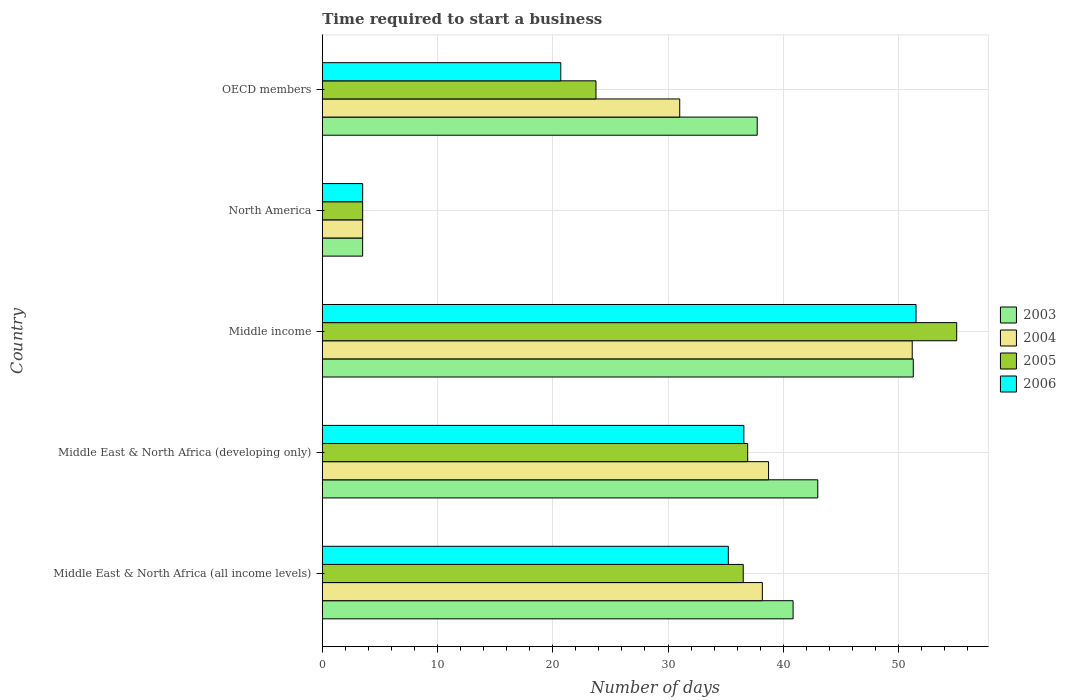How many different coloured bars are there?
Provide a succinct answer. 4. How many groups of bars are there?
Ensure brevity in your answer.  5. How many bars are there on the 5th tick from the bottom?
Ensure brevity in your answer.  4. What is the label of the 5th group of bars from the top?
Provide a succinct answer. Middle East & North Africa (all income levels). What is the number of days required to start a business in 2005 in North America?
Keep it short and to the point. 3.5. Across all countries, what is the maximum number of days required to start a business in 2003?
Offer a very short reply. 51.29. Across all countries, what is the minimum number of days required to start a business in 2006?
Offer a terse response. 3.5. In which country was the number of days required to start a business in 2005 minimum?
Your answer should be compact. North America. What is the total number of days required to start a business in 2004 in the graph?
Provide a succinct answer. 162.63. What is the difference between the number of days required to start a business in 2004 in Middle East & North Africa (all income levels) and that in Middle East & North Africa (developing only)?
Your answer should be compact. -0.54. What is the difference between the number of days required to start a business in 2004 in Middle East & North Africa (all income levels) and the number of days required to start a business in 2005 in North America?
Your answer should be very brief. 34.69. What is the average number of days required to start a business in 2003 per country?
Provide a short and direct response. 35.28. What is the difference between the number of days required to start a business in 2006 and number of days required to start a business in 2004 in OECD members?
Make the answer very short. -10.32. In how many countries, is the number of days required to start a business in 2004 greater than 38 days?
Ensure brevity in your answer.  3. What is the ratio of the number of days required to start a business in 2006 in Middle income to that in North America?
Give a very brief answer. 14.72. Is the number of days required to start a business in 2006 in Middle East & North Africa (all income levels) less than that in OECD members?
Keep it short and to the point. No. Is the difference between the number of days required to start a business in 2006 in Middle East & North Africa (all income levels) and Middle income greater than the difference between the number of days required to start a business in 2004 in Middle East & North Africa (all income levels) and Middle income?
Your answer should be very brief. No. What is the difference between the highest and the second highest number of days required to start a business in 2004?
Offer a very short reply. 12.47. What is the difference between the highest and the lowest number of days required to start a business in 2005?
Your answer should be very brief. 51.56. Is the sum of the number of days required to start a business in 2006 in Middle East & North Africa (all income levels) and North America greater than the maximum number of days required to start a business in 2004 across all countries?
Your answer should be very brief. No. Is it the case that in every country, the sum of the number of days required to start a business in 2006 and number of days required to start a business in 2003 is greater than the sum of number of days required to start a business in 2005 and number of days required to start a business in 2004?
Ensure brevity in your answer.  No. What does the 4th bar from the bottom in Middle East & North Africa (developing only) represents?
Ensure brevity in your answer.  2006. How many countries are there in the graph?
Offer a very short reply. 5. Does the graph contain any zero values?
Offer a very short reply. No. Where does the legend appear in the graph?
Keep it short and to the point. Center right. How many legend labels are there?
Your answer should be very brief. 4. What is the title of the graph?
Your response must be concise. Time required to start a business. Does "2009" appear as one of the legend labels in the graph?
Provide a succinct answer. No. What is the label or title of the X-axis?
Your response must be concise. Number of days. What is the label or title of the Y-axis?
Your response must be concise. Country. What is the Number of days of 2003 in Middle East & North Africa (all income levels)?
Provide a succinct answer. 40.86. What is the Number of days of 2004 in Middle East & North Africa (all income levels)?
Your answer should be compact. 38.19. What is the Number of days of 2005 in Middle East & North Africa (all income levels)?
Offer a terse response. 36.53. What is the Number of days in 2006 in Middle East & North Africa (all income levels)?
Offer a very short reply. 35.24. What is the Number of days in 2004 in Middle East & North Africa (developing only)?
Offer a very short reply. 38.73. What is the Number of days in 2005 in Middle East & North Africa (developing only)?
Your response must be concise. 36.92. What is the Number of days of 2006 in Middle East & North Africa (developing only)?
Ensure brevity in your answer.  36.58. What is the Number of days in 2003 in Middle income?
Offer a terse response. 51.29. What is the Number of days of 2004 in Middle income?
Provide a succinct answer. 51.19. What is the Number of days of 2005 in Middle income?
Your answer should be compact. 55.06. What is the Number of days in 2006 in Middle income?
Provide a short and direct response. 51.53. What is the Number of days in 2003 in North America?
Offer a terse response. 3.5. What is the Number of days in 2006 in North America?
Offer a very short reply. 3.5. What is the Number of days of 2003 in OECD members?
Keep it short and to the point. 37.74. What is the Number of days in 2004 in OECD members?
Your answer should be compact. 31.02. What is the Number of days of 2005 in OECD members?
Provide a short and direct response. 23.75. What is the Number of days in 2006 in OECD members?
Ensure brevity in your answer.  20.69. Across all countries, what is the maximum Number of days in 2003?
Provide a short and direct response. 51.29. Across all countries, what is the maximum Number of days of 2004?
Your response must be concise. 51.19. Across all countries, what is the maximum Number of days in 2005?
Ensure brevity in your answer.  55.06. Across all countries, what is the maximum Number of days in 2006?
Provide a short and direct response. 51.53. Across all countries, what is the minimum Number of days in 2005?
Offer a terse response. 3.5. Across all countries, what is the minimum Number of days of 2006?
Your answer should be very brief. 3.5. What is the total Number of days of 2003 in the graph?
Ensure brevity in your answer.  176.38. What is the total Number of days of 2004 in the graph?
Give a very brief answer. 162.63. What is the total Number of days of 2005 in the graph?
Provide a short and direct response. 155.75. What is the total Number of days of 2006 in the graph?
Offer a very short reply. 147.54. What is the difference between the Number of days of 2003 in Middle East & North Africa (all income levels) and that in Middle East & North Africa (developing only)?
Offer a terse response. -2.14. What is the difference between the Number of days in 2004 in Middle East & North Africa (all income levels) and that in Middle East & North Africa (developing only)?
Ensure brevity in your answer.  -0.54. What is the difference between the Number of days of 2005 in Middle East & North Africa (all income levels) and that in Middle East & North Africa (developing only)?
Offer a terse response. -0.39. What is the difference between the Number of days in 2006 in Middle East & North Africa (all income levels) and that in Middle East & North Africa (developing only)?
Give a very brief answer. -1.35. What is the difference between the Number of days in 2003 in Middle East & North Africa (all income levels) and that in Middle income?
Provide a succinct answer. -10.43. What is the difference between the Number of days of 2004 in Middle East & North Africa (all income levels) and that in Middle income?
Make the answer very short. -13.01. What is the difference between the Number of days of 2005 in Middle East & North Africa (all income levels) and that in Middle income?
Offer a terse response. -18.53. What is the difference between the Number of days of 2006 in Middle East & North Africa (all income levels) and that in Middle income?
Provide a short and direct response. -16.29. What is the difference between the Number of days of 2003 in Middle East & North Africa (all income levels) and that in North America?
Your answer should be compact. 37.36. What is the difference between the Number of days of 2004 in Middle East & North Africa (all income levels) and that in North America?
Offer a very short reply. 34.69. What is the difference between the Number of days in 2005 in Middle East & North Africa (all income levels) and that in North America?
Provide a short and direct response. 33.03. What is the difference between the Number of days in 2006 in Middle East & North Africa (all income levels) and that in North America?
Provide a short and direct response. 31.74. What is the difference between the Number of days of 2003 in Middle East & North Africa (all income levels) and that in OECD members?
Offer a very short reply. 3.12. What is the difference between the Number of days in 2004 in Middle East & North Africa (all income levels) and that in OECD members?
Give a very brief answer. 7.17. What is the difference between the Number of days of 2005 in Middle East & North Africa (all income levels) and that in OECD members?
Your answer should be compact. 12.78. What is the difference between the Number of days of 2006 in Middle East & North Africa (all income levels) and that in OECD members?
Provide a succinct answer. 14.54. What is the difference between the Number of days of 2003 in Middle East & North Africa (developing only) and that in Middle income?
Offer a very short reply. -8.29. What is the difference between the Number of days in 2004 in Middle East & North Africa (developing only) and that in Middle income?
Your answer should be compact. -12.47. What is the difference between the Number of days of 2005 in Middle East & North Africa (developing only) and that in Middle income?
Give a very brief answer. -18.14. What is the difference between the Number of days of 2006 in Middle East & North Africa (developing only) and that in Middle income?
Your response must be concise. -14.94. What is the difference between the Number of days of 2003 in Middle East & North Africa (developing only) and that in North America?
Give a very brief answer. 39.5. What is the difference between the Number of days in 2004 in Middle East & North Africa (developing only) and that in North America?
Offer a terse response. 35.23. What is the difference between the Number of days of 2005 in Middle East & North Africa (developing only) and that in North America?
Give a very brief answer. 33.42. What is the difference between the Number of days of 2006 in Middle East & North Africa (developing only) and that in North America?
Provide a short and direct response. 33.08. What is the difference between the Number of days of 2003 in Middle East & North Africa (developing only) and that in OECD members?
Offer a terse response. 5.26. What is the difference between the Number of days of 2004 in Middle East & North Africa (developing only) and that in OECD members?
Give a very brief answer. 7.71. What is the difference between the Number of days in 2005 in Middle East & North Africa (developing only) and that in OECD members?
Ensure brevity in your answer.  13.17. What is the difference between the Number of days in 2006 in Middle East & North Africa (developing only) and that in OECD members?
Your answer should be very brief. 15.89. What is the difference between the Number of days of 2003 in Middle income and that in North America?
Provide a short and direct response. 47.79. What is the difference between the Number of days of 2004 in Middle income and that in North America?
Offer a terse response. 47.69. What is the difference between the Number of days of 2005 in Middle income and that in North America?
Ensure brevity in your answer.  51.56. What is the difference between the Number of days of 2006 in Middle income and that in North America?
Keep it short and to the point. 48.03. What is the difference between the Number of days in 2003 in Middle income and that in OECD members?
Your answer should be very brief. 13.54. What is the difference between the Number of days of 2004 in Middle income and that in OECD members?
Your answer should be very brief. 20.18. What is the difference between the Number of days of 2005 in Middle income and that in OECD members?
Provide a succinct answer. 31.31. What is the difference between the Number of days in 2006 in Middle income and that in OECD members?
Make the answer very short. 30.83. What is the difference between the Number of days in 2003 in North America and that in OECD members?
Make the answer very short. -34.24. What is the difference between the Number of days in 2004 in North America and that in OECD members?
Keep it short and to the point. -27.52. What is the difference between the Number of days of 2005 in North America and that in OECD members?
Provide a short and direct response. -20.25. What is the difference between the Number of days of 2006 in North America and that in OECD members?
Offer a terse response. -17.19. What is the difference between the Number of days in 2003 in Middle East & North Africa (all income levels) and the Number of days in 2004 in Middle East & North Africa (developing only)?
Ensure brevity in your answer.  2.13. What is the difference between the Number of days in 2003 in Middle East & North Africa (all income levels) and the Number of days in 2005 in Middle East & North Africa (developing only)?
Your response must be concise. 3.94. What is the difference between the Number of days of 2003 in Middle East & North Africa (all income levels) and the Number of days of 2006 in Middle East & North Africa (developing only)?
Your response must be concise. 4.27. What is the difference between the Number of days in 2004 in Middle East & North Africa (all income levels) and the Number of days in 2005 in Middle East & North Africa (developing only)?
Offer a very short reply. 1.27. What is the difference between the Number of days of 2004 in Middle East & North Africa (all income levels) and the Number of days of 2006 in Middle East & North Africa (developing only)?
Ensure brevity in your answer.  1.6. What is the difference between the Number of days of 2005 in Middle East & North Africa (all income levels) and the Number of days of 2006 in Middle East & North Africa (developing only)?
Your response must be concise. -0.05. What is the difference between the Number of days in 2003 in Middle East & North Africa (all income levels) and the Number of days in 2004 in Middle income?
Give a very brief answer. -10.34. What is the difference between the Number of days in 2003 in Middle East & North Africa (all income levels) and the Number of days in 2005 in Middle income?
Your answer should be very brief. -14.2. What is the difference between the Number of days of 2003 in Middle East & North Africa (all income levels) and the Number of days of 2006 in Middle income?
Keep it short and to the point. -10.67. What is the difference between the Number of days in 2004 in Middle East & North Africa (all income levels) and the Number of days in 2005 in Middle income?
Your response must be concise. -16.87. What is the difference between the Number of days of 2004 in Middle East & North Africa (all income levels) and the Number of days of 2006 in Middle income?
Give a very brief answer. -13.34. What is the difference between the Number of days of 2005 in Middle East & North Africa (all income levels) and the Number of days of 2006 in Middle income?
Offer a very short reply. -15. What is the difference between the Number of days of 2003 in Middle East & North Africa (all income levels) and the Number of days of 2004 in North America?
Offer a terse response. 37.36. What is the difference between the Number of days of 2003 in Middle East & North Africa (all income levels) and the Number of days of 2005 in North America?
Your response must be concise. 37.36. What is the difference between the Number of days of 2003 in Middle East & North Africa (all income levels) and the Number of days of 2006 in North America?
Provide a succinct answer. 37.36. What is the difference between the Number of days in 2004 in Middle East & North Africa (all income levels) and the Number of days in 2005 in North America?
Your response must be concise. 34.69. What is the difference between the Number of days of 2004 in Middle East & North Africa (all income levels) and the Number of days of 2006 in North America?
Keep it short and to the point. 34.69. What is the difference between the Number of days in 2005 in Middle East & North Africa (all income levels) and the Number of days in 2006 in North America?
Keep it short and to the point. 33.03. What is the difference between the Number of days in 2003 in Middle East & North Africa (all income levels) and the Number of days in 2004 in OECD members?
Provide a succinct answer. 9.84. What is the difference between the Number of days of 2003 in Middle East & North Africa (all income levels) and the Number of days of 2005 in OECD members?
Make the answer very short. 17.11. What is the difference between the Number of days of 2003 in Middle East & North Africa (all income levels) and the Number of days of 2006 in OECD members?
Provide a short and direct response. 20.16. What is the difference between the Number of days in 2004 in Middle East & North Africa (all income levels) and the Number of days in 2005 in OECD members?
Make the answer very short. 14.44. What is the difference between the Number of days in 2004 in Middle East & North Africa (all income levels) and the Number of days in 2006 in OECD members?
Offer a very short reply. 17.49. What is the difference between the Number of days in 2005 in Middle East & North Africa (all income levels) and the Number of days in 2006 in OECD members?
Offer a terse response. 15.84. What is the difference between the Number of days of 2003 in Middle East & North Africa (developing only) and the Number of days of 2004 in Middle income?
Your answer should be very brief. -8.19. What is the difference between the Number of days of 2003 in Middle East & North Africa (developing only) and the Number of days of 2005 in Middle income?
Offer a very short reply. -12.06. What is the difference between the Number of days of 2003 in Middle East & North Africa (developing only) and the Number of days of 2006 in Middle income?
Your answer should be compact. -8.53. What is the difference between the Number of days in 2004 in Middle East & North Africa (developing only) and the Number of days in 2005 in Middle income?
Provide a succinct answer. -16.33. What is the difference between the Number of days of 2004 in Middle East & North Africa (developing only) and the Number of days of 2006 in Middle income?
Provide a succinct answer. -12.8. What is the difference between the Number of days of 2005 in Middle East & North Africa (developing only) and the Number of days of 2006 in Middle income?
Your answer should be very brief. -14.61. What is the difference between the Number of days in 2003 in Middle East & North Africa (developing only) and the Number of days in 2004 in North America?
Ensure brevity in your answer.  39.5. What is the difference between the Number of days in 2003 in Middle East & North Africa (developing only) and the Number of days in 2005 in North America?
Offer a very short reply. 39.5. What is the difference between the Number of days in 2003 in Middle East & North Africa (developing only) and the Number of days in 2006 in North America?
Your answer should be very brief. 39.5. What is the difference between the Number of days in 2004 in Middle East & North Africa (developing only) and the Number of days in 2005 in North America?
Your response must be concise. 35.23. What is the difference between the Number of days of 2004 in Middle East & North Africa (developing only) and the Number of days of 2006 in North America?
Your answer should be compact. 35.23. What is the difference between the Number of days in 2005 in Middle East & North Africa (developing only) and the Number of days in 2006 in North America?
Offer a terse response. 33.42. What is the difference between the Number of days in 2003 in Middle East & North Africa (developing only) and the Number of days in 2004 in OECD members?
Provide a succinct answer. 11.98. What is the difference between the Number of days of 2003 in Middle East & North Africa (developing only) and the Number of days of 2005 in OECD members?
Ensure brevity in your answer.  19.25. What is the difference between the Number of days in 2003 in Middle East & North Africa (developing only) and the Number of days in 2006 in OECD members?
Your answer should be very brief. 22.31. What is the difference between the Number of days of 2004 in Middle East & North Africa (developing only) and the Number of days of 2005 in OECD members?
Your response must be concise. 14.98. What is the difference between the Number of days of 2004 in Middle East & North Africa (developing only) and the Number of days of 2006 in OECD members?
Make the answer very short. 18.03. What is the difference between the Number of days in 2005 in Middle East & North Africa (developing only) and the Number of days in 2006 in OECD members?
Keep it short and to the point. 16.22. What is the difference between the Number of days of 2003 in Middle income and the Number of days of 2004 in North America?
Your response must be concise. 47.79. What is the difference between the Number of days of 2003 in Middle income and the Number of days of 2005 in North America?
Ensure brevity in your answer.  47.79. What is the difference between the Number of days in 2003 in Middle income and the Number of days in 2006 in North America?
Give a very brief answer. 47.79. What is the difference between the Number of days of 2004 in Middle income and the Number of days of 2005 in North America?
Offer a terse response. 47.69. What is the difference between the Number of days in 2004 in Middle income and the Number of days in 2006 in North America?
Your answer should be very brief. 47.69. What is the difference between the Number of days of 2005 in Middle income and the Number of days of 2006 in North America?
Keep it short and to the point. 51.56. What is the difference between the Number of days of 2003 in Middle income and the Number of days of 2004 in OECD members?
Offer a very short reply. 20.27. What is the difference between the Number of days in 2003 in Middle income and the Number of days in 2005 in OECD members?
Provide a short and direct response. 27.54. What is the difference between the Number of days in 2003 in Middle income and the Number of days in 2006 in OECD members?
Provide a succinct answer. 30.59. What is the difference between the Number of days of 2004 in Middle income and the Number of days of 2005 in OECD members?
Make the answer very short. 27.44. What is the difference between the Number of days of 2004 in Middle income and the Number of days of 2006 in OECD members?
Keep it short and to the point. 30.5. What is the difference between the Number of days in 2005 in Middle income and the Number of days in 2006 in OECD members?
Give a very brief answer. 34.36. What is the difference between the Number of days of 2003 in North America and the Number of days of 2004 in OECD members?
Make the answer very short. -27.52. What is the difference between the Number of days of 2003 in North America and the Number of days of 2005 in OECD members?
Give a very brief answer. -20.25. What is the difference between the Number of days of 2003 in North America and the Number of days of 2006 in OECD members?
Provide a succinct answer. -17.19. What is the difference between the Number of days of 2004 in North America and the Number of days of 2005 in OECD members?
Offer a terse response. -20.25. What is the difference between the Number of days in 2004 in North America and the Number of days in 2006 in OECD members?
Keep it short and to the point. -17.19. What is the difference between the Number of days of 2005 in North America and the Number of days of 2006 in OECD members?
Your answer should be very brief. -17.19. What is the average Number of days of 2003 per country?
Provide a succinct answer. 35.28. What is the average Number of days of 2004 per country?
Offer a terse response. 32.53. What is the average Number of days in 2005 per country?
Your answer should be very brief. 31.15. What is the average Number of days of 2006 per country?
Your answer should be compact. 29.51. What is the difference between the Number of days of 2003 and Number of days of 2004 in Middle East & North Africa (all income levels)?
Your response must be concise. 2.67. What is the difference between the Number of days in 2003 and Number of days in 2005 in Middle East & North Africa (all income levels)?
Offer a terse response. 4.33. What is the difference between the Number of days of 2003 and Number of days of 2006 in Middle East & North Africa (all income levels)?
Your response must be concise. 5.62. What is the difference between the Number of days in 2004 and Number of days in 2005 in Middle East & North Africa (all income levels)?
Your answer should be very brief. 1.66. What is the difference between the Number of days in 2004 and Number of days in 2006 in Middle East & North Africa (all income levels)?
Your response must be concise. 2.95. What is the difference between the Number of days in 2005 and Number of days in 2006 in Middle East & North Africa (all income levels)?
Provide a succinct answer. 1.29. What is the difference between the Number of days in 2003 and Number of days in 2004 in Middle East & North Africa (developing only)?
Make the answer very short. 4.27. What is the difference between the Number of days in 2003 and Number of days in 2005 in Middle East & North Africa (developing only)?
Ensure brevity in your answer.  6.08. What is the difference between the Number of days of 2003 and Number of days of 2006 in Middle East & North Africa (developing only)?
Keep it short and to the point. 6.42. What is the difference between the Number of days of 2004 and Number of days of 2005 in Middle East & North Africa (developing only)?
Ensure brevity in your answer.  1.81. What is the difference between the Number of days of 2004 and Number of days of 2006 in Middle East & North Africa (developing only)?
Your response must be concise. 2.14. What is the difference between the Number of days in 2003 and Number of days in 2004 in Middle income?
Make the answer very short. 0.09. What is the difference between the Number of days of 2003 and Number of days of 2005 in Middle income?
Your answer should be compact. -3.77. What is the difference between the Number of days of 2003 and Number of days of 2006 in Middle income?
Keep it short and to the point. -0.24. What is the difference between the Number of days of 2004 and Number of days of 2005 in Middle income?
Provide a short and direct response. -3.86. What is the difference between the Number of days of 2004 and Number of days of 2006 in Middle income?
Give a very brief answer. -0.33. What is the difference between the Number of days in 2005 and Number of days in 2006 in Middle income?
Your response must be concise. 3.53. What is the difference between the Number of days of 2003 and Number of days of 2005 in North America?
Provide a succinct answer. 0. What is the difference between the Number of days in 2004 and Number of days in 2006 in North America?
Give a very brief answer. 0. What is the difference between the Number of days in 2005 and Number of days in 2006 in North America?
Give a very brief answer. 0. What is the difference between the Number of days of 2003 and Number of days of 2004 in OECD members?
Offer a very short reply. 6.72. What is the difference between the Number of days of 2003 and Number of days of 2005 in OECD members?
Offer a terse response. 13.99. What is the difference between the Number of days in 2003 and Number of days in 2006 in OECD members?
Offer a very short reply. 17.05. What is the difference between the Number of days in 2004 and Number of days in 2005 in OECD members?
Ensure brevity in your answer.  7.27. What is the difference between the Number of days of 2004 and Number of days of 2006 in OECD members?
Make the answer very short. 10.32. What is the difference between the Number of days in 2005 and Number of days in 2006 in OECD members?
Offer a terse response. 3.06. What is the ratio of the Number of days of 2003 in Middle East & North Africa (all income levels) to that in Middle East & North Africa (developing only)?
Your response must be concise. 0.95. What is the ratio of the Number of days in 2004 in Middle East & North Africa (all income levels) to that in Middle East & North Africa (developing only)?
Ensure brevity in your answer.  0.99. What is the ratio of the Number of days in 2006 in Middle East & North Africa (all income levels) to that in Middle East & North Africa (developing only)?
Keep it short and to the point. 0.96. What is the ratio of the Number of days in 2003 in Middle East & North Africa (all income levels) to that in Middle income?
Offer a terse response. 0.8. What is the ratio of the Number of days of 2004 in Middle East & North Africa (all income levels) to that in Middle income?
Your answer should be very brief. 0.75. What is the ratio of the Number of days in 2005 in Middle East & North Africa (all income levels) to that in Middle income?
Keep it short and to the point. 0.66. What is the ratio of the Number of days of 2006 in Middle East & North Africa (all income levels) to that in Middle income?
Offer a terse response. 0.68. What is the ratio of the Number of days in 2003 in Middle East & North Africa (all income levels) to that in North America?
Offer a very short reply. 11.67. What is the ratio of the Number of days of 2004 in Middle East & North Africa (all income levels) to that in North America?
Ensure brevity in your answer.  10.91. What is the ratio of the Number of days in 2005 in Middle East & North Africa (all income levels) to that in North America?
Your response must be concise. 10.44. What is the ratio of the Number of days of 2006 in Middle East & North Africa (all income levels) to that in North America?
Your answer should be compact. 10.07. What is the ratio of the Number of days of 2003 in Middle East & North Africa (all income levels) to that in OECD members?
Offer a terse response. 1.08. What is the ratio of the Number of days of 2004 in Middle East & North Africa (all income levels) to that in OECD members?
Ensure brevity in your answer.  1.23. What is the ratio of the Number of days in 2005 in Middle East & North Africa (all income levels) to that in OECD members?
Provide a succinct answer. 1.54. What is the ratio of the Number of days of 2006 in Middle East & North Africa (all income levels) to that in OECD members?
Keep it short and to the point. 1.7. What is the ratio of the Number of days in 2003 in Middle East & North Africa (developing only) to that in Middle income?
Your answer should be very brief. 0.84. What is the ratio of the Number of days of 2004 in Middle East & North Africa (developing only) to that in Middle income?
Offer a very short reply. 0.76. What is the ratio of the Number of days in 2005 in Middle East & North Africa (developing only) to that in Middle income?
Make the answer very short. 0.67. What is the ratio of the Number of days in 2006 in Middle East & North Africa (developing only) to that in Middle income?
Your response must be concise. 0.71. What is the ratio of the Number of days in 2003 in Middle East & North Africa (developing only) to that in North America?
Keep it short and to the point. 12.29. What is the ratio of the Number of days in 2004 in Middle East & North Africa (developing only) to that in North America?
Your response must be concise. 11.06. What is the ratio of the Number of days of 2005 in Middle East & North Africa (developing only) to that in North America?
Provide a short and direct response. 10.55. What is the ratio of the Number of days of 2006 in Middle East & North Africa (developing only) to that in North America?
Give a very brief answer. 10.45. What is the ratio of the Number of days in 2003 in Middle East & North Africa (developing only) to that in OECD members?
Give a very brief answer. 1.14. What is the ratio of the Number of days of 2004 in Middle East & North Africa (developing only) to that in OECD members?
Your answer should be compact. 1.25. What is the ratio of the Number of days in 2005 in Middle East & North Africa (developing only) to that in OECD members?
Your answer should be very brief. 1.55. What is the ratio of the Number of days of 2006 in Middle East & North Africa (developing only) to that in OECD members?
Keep it short and to the point. 1.77. What is the ratio of the Number of days in 2003 in Middle income to that in North America?
Make the answer very short. 14.65. What is the ratio of the Number of days of 2004 in Middle income to that in North America?
Give a very brief answer. 14.63. What is the ratio of the Number of days in 2005 in Middle income to that in North America?
Provide a short and direct response. 15.73. What is the ratio of the Number of days of 2006 in Middle income to that in North America?
Ensure brevity in your answer.  14.72. What is the ratio of the Number of days of 2003 in Middle income to that in OECD members?
Your answer should be very brief. 1.36. What is the ratio of the Number of days of 2004 in Middle income to that in OECD members?
Your response must be concise. 1.65. What is the ratio of the Number of days of 2005 in Middle income to that in OECD members?
Give a very brief answer. 2.32. What is the ratio of the Number of days of 2006 in Middle income to that in OECD members?
Offer a terse response. 2.49. What is the ratio of the Number of days of 2003 in North America to that in OECD members?
Provide a succinct answer. 0.09. What is the ratio of the Number of days of 2004 in North America to that in OECD members?
Give a very brief answer. 0.11. What is the ratio of the Number of days in 2005 in North America to that in OECD members?
Your answer should be compact. 0.15. What is the ratio of the Number of days of 2006 in North America to that in OECD members?
Your response must be concise. 0.17. What is the difference between the highest and the second highest Number of days in 2003?
Ensure brevity in your answer.  8.29. What is the difference between the highest and the second highest Number of days of 2004?
Offer a terse response. 12.47. What is the difference between the highest and the second highest Number of days in 2005?
Ensure brevity in your answer.  18.14. What is the difference between the highest and the second highest Number of days in 2006?
Offer a terse response. 14.94. What is the difference between the highest and the lowest Number of days of 2003?
Offer a terse response. 47.79. What is the difference between the highest and the lowest Number of days of 2004?
Keep it short and to the point. 47.69. What is the difference between the highest and the lowest Number of days of 2005?
Offer a very short reply. 51.56. What is the difference between the highest and the lowest Number of days in 2006?
Provide a succinct answer. 48.03. 